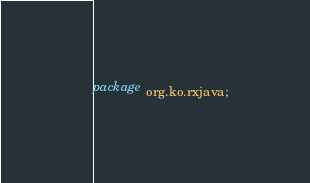<code> <loc_0><loc_0><loc_500><loc_500><_Java_>package org.ko.rxjava;</code> 